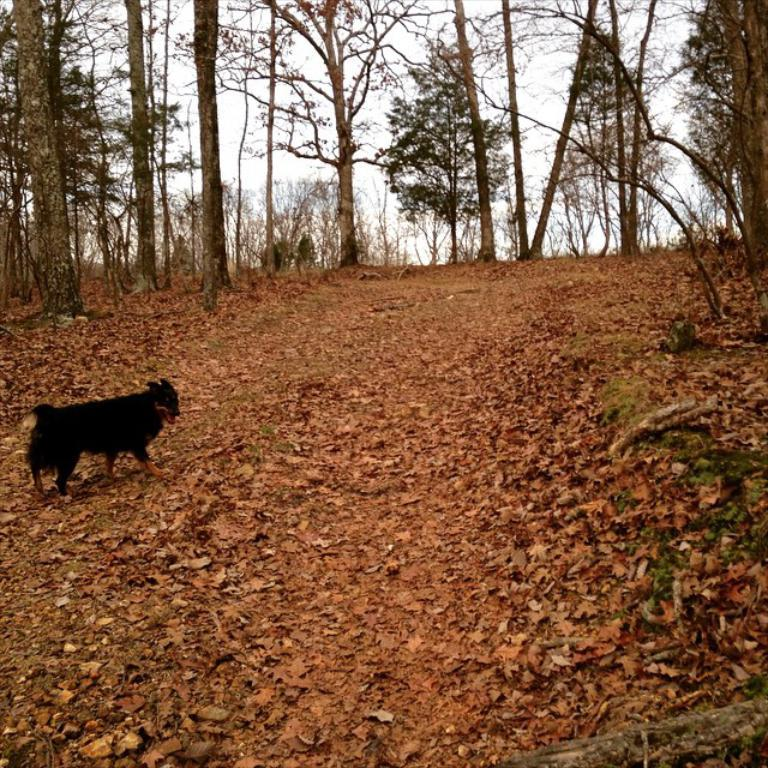What type of animal is present in the image? There is a dog in the image. What can be seen in the background of the image? There are many trees in the image. What is on the ground in the image? There are many dry leaves on the ground. What is visible above the trees in the image? There is a sky visible in the image. What type of pest can be seen crawling on the dog in the image? There is no pest visible on the dog in the image. What metal object is being used by the dog to dig in the ground? There is no metal object present in the image, and the dog is not digging in the ground. 